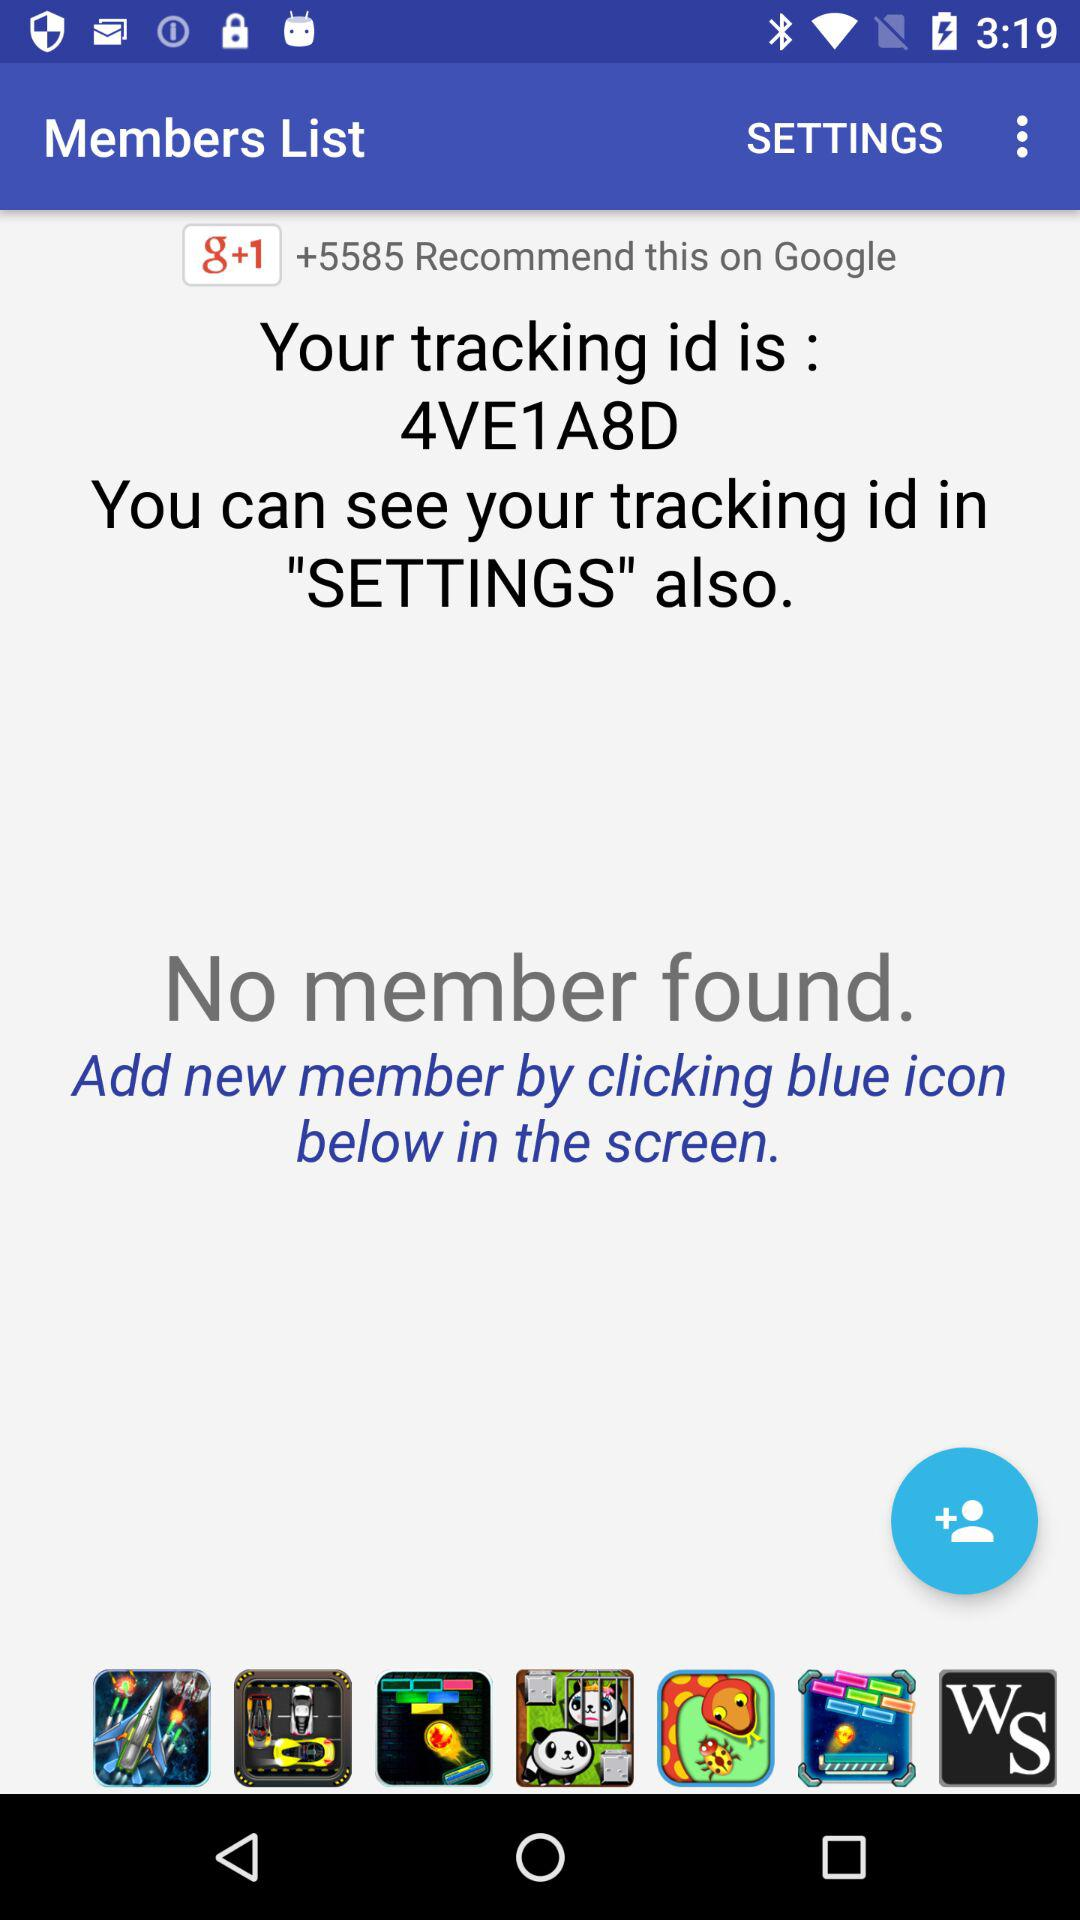What is the tracking ID? The tracking ID is 4VE1A8D. 